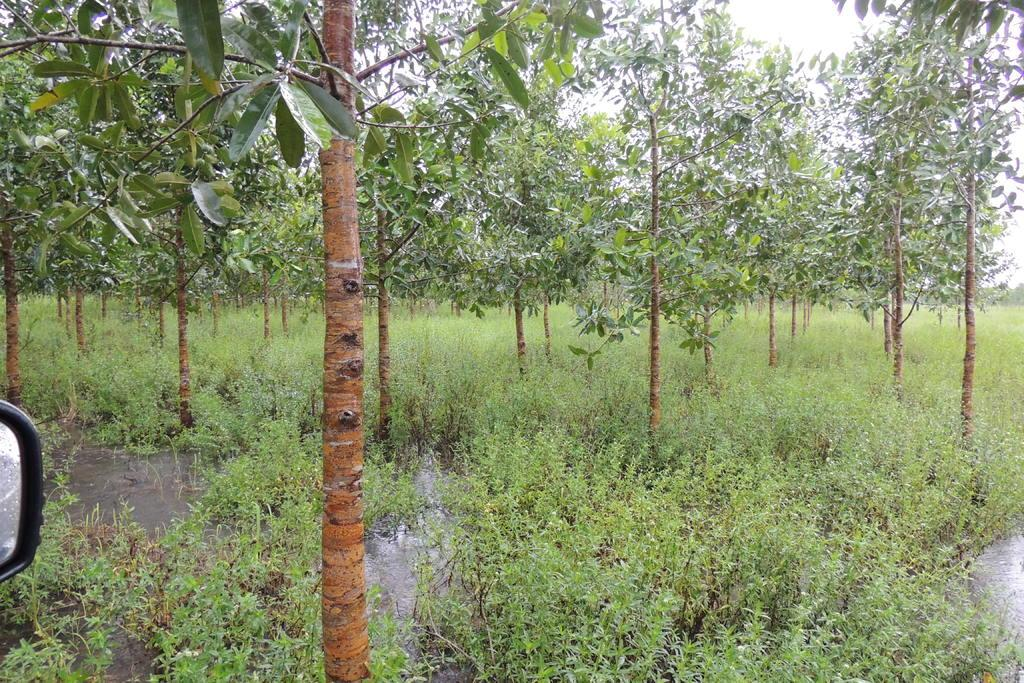What type of vegetation can be seen in the image? There are trees and plants in the image. What is visible at the bottom of the image? There is water visible at the bottom of the image. Can you describe the plot of land where the tiger is resting in the image? There is no tiger present in the image; it only features trees, plants, and water. 